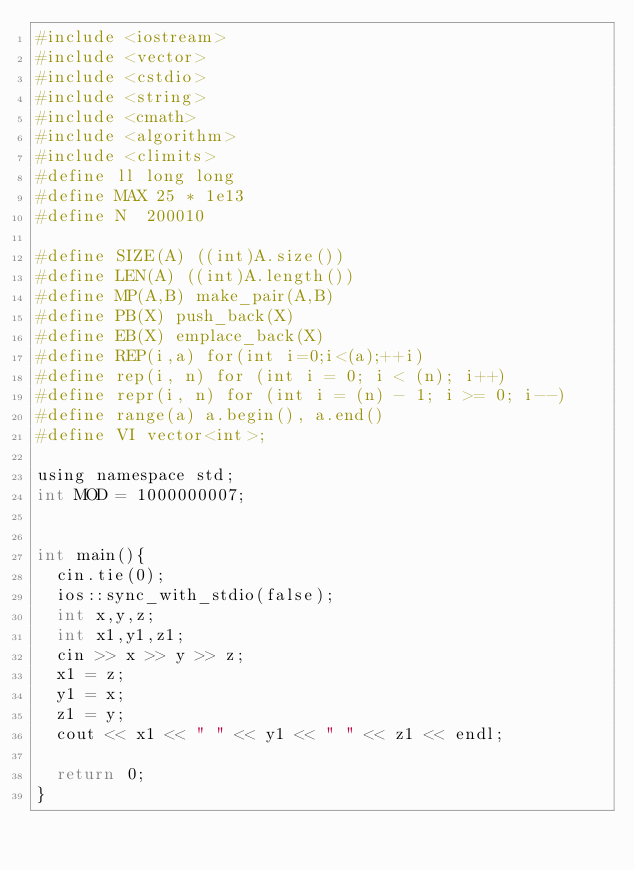<code> <loc_0><loc_0><loc_500><loc_500><_Python_>#include <iostream>
#include <vector>
#include <cstdio>
#include <string>
#include <cmath>
#include <algorithm>
#include <climits>
#define ll long long
#define MAX 25 * 1e13
#define N  200010

#define SIZE(A) ((int)A.size())
#define LEN(A) ((int)A.length())
#define MP(A,B) make_pair(A,B)
#define PB(X) push_back(X)
#define EB(X) emplace_back(X)
#define REP(i,a) for(int i=0;i<(a);++i)
#define rep(i, n) for (int i = 0; i < (n); i++)
#define repr(i, n) for (int i = (n) - 1; i >= 0; i--)
#define range(a) a.begin(), a.end()
#define VI vector<int>;

using namespace std;
int MOD = 1000000007;


int main(){
  cin.tie(0);
  ios::sync_with_stdio(false);
  int x,y,z;
  int x1,y1,z1;
  cin >> x >> y >> z;
  x1 = z;
  y1 = x;
  z1 = y;
  cout << x1 << " " << y1 << " " << z1 << endl;

  return 0;
}

</code> 